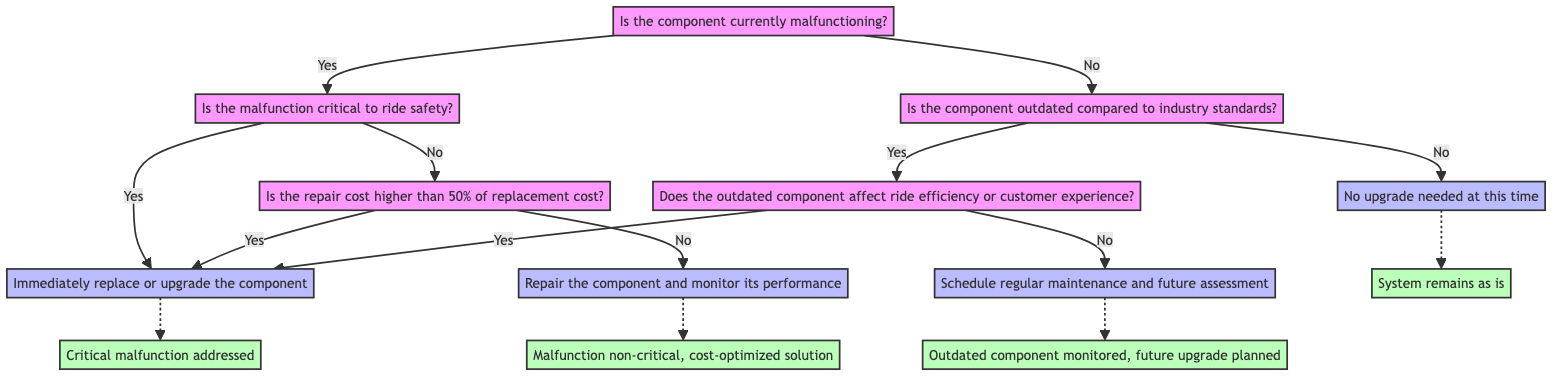What is the first question in the decision tree? The first question in the decision tree is located at Node1, which asks, "Is the component currently malfunctioning?"
Answer: Is the component currently malfunctioning? How many action nodes are present in the diagram? By analyzing the diagram, we identify four action nodes: Node4, Node7, Node8, and Node9.
Answer: Four What happens if the component is outdated and affects ride efficiency? Following the path for an outdated component affecting ride efficiency, we find that the decision leads to Node4, resulting in "Immediately replace or upgrade the component."
Answer: Immediately replace or upgrade the component What is the outcome if the malfunction is critical to ride safety? The flow from Node2 (if the malfunction is critical) leads directly to Node4, which specifies the outcome as "Critical malfunction addressed."
Answer: Critical malfunction addressed What is the action taken if the repair cost is less than 50% of replacement cost and the malfunction is non-critical? In this scenario, the flow leads to Node8, where the action specified is "Repair the component and monitor its performance."
Answer: Repair the component and monitor its performance What does the diagram state if the component is not outdated? If the component is not outdated according to Node3, it directly leads to Node7, where the action is "No upgrade needed at this time."
Answer: No upgrade needed at this time If both the malfunction is non-critical and repair cost is high, what occurs? In this case, the decision tree shows that we would replace or upgrade the component (Node4) as the path from Node2 leads to DC when the repair cost is deemed high.
Answer: Immediately replace or upgrade the component What is the outcome when an outdated component does not affect ride efficiency? Following the path from Node6 for an outdated component that does not affect ride efficiency leads to Node9, resulting in "Outdated component monitored, future upgrade planned."
Answer: Outdated component monitored, future upgrade planned 